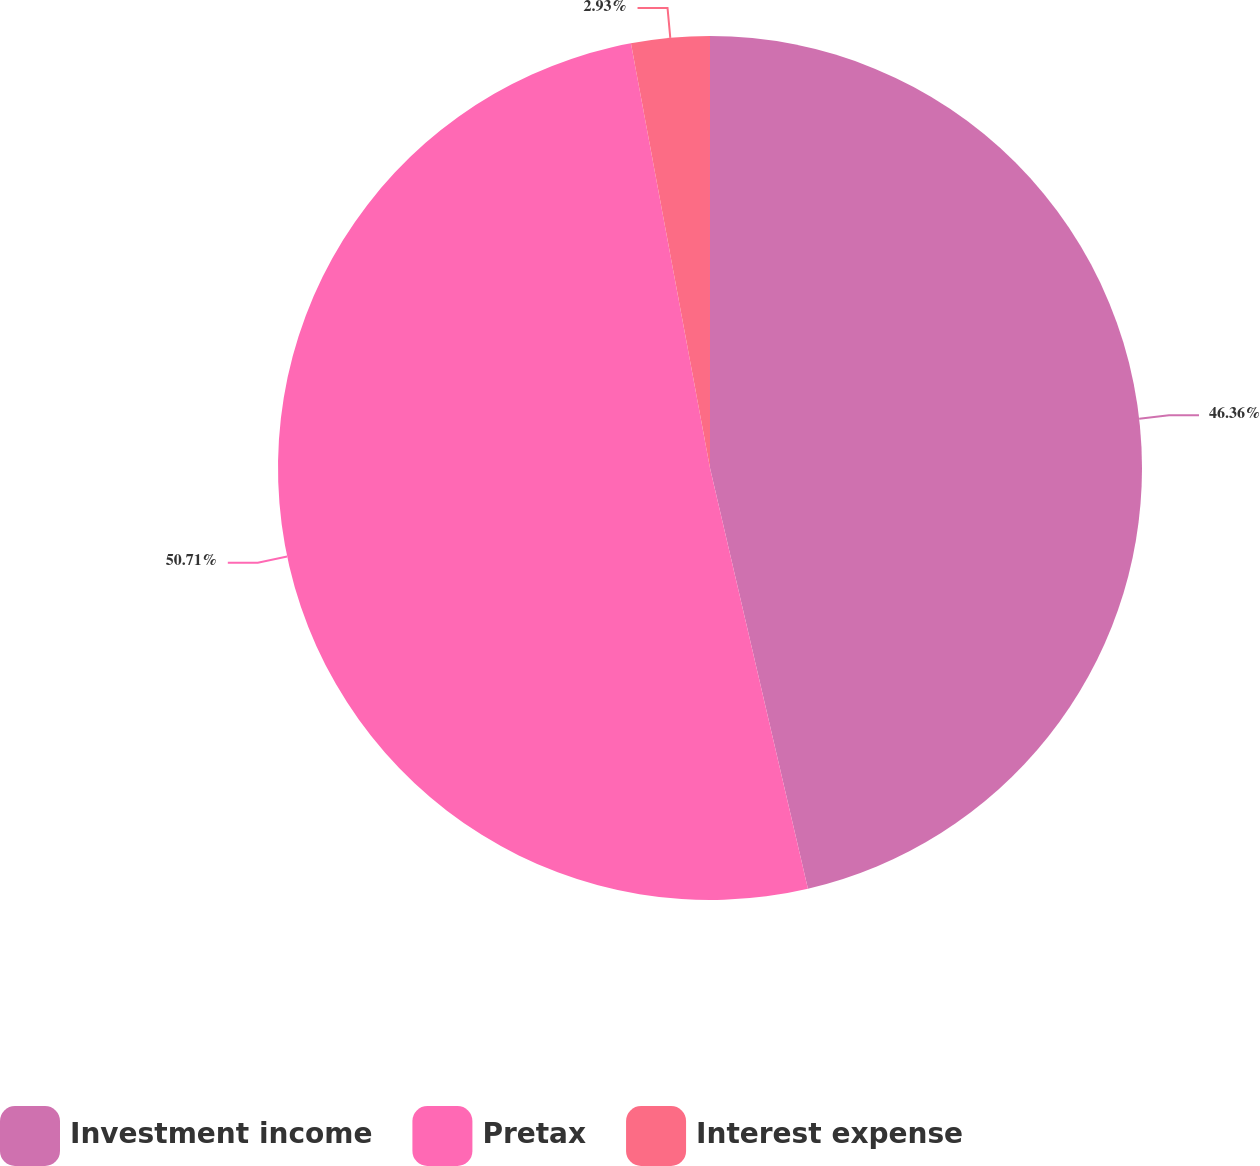<chart> <loc_0><loc_0><loc_500><loc_500><pie_chart><fcel>Investment income<fcel>Pretax<fcel>Interest expense<nl><fcel>46.36%<fcel>50.71%<fcel>2.93%<nl></chart> 